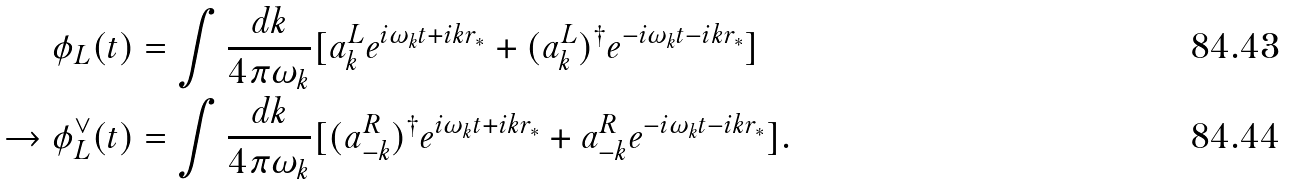<formula> <loc_0><loc_0><loc_500><loc_500>\phi _ { L } ( t ) & = \int \frac { d k } { 4 \pi \omega _ { k } } [ a ^ { L } _ { k } e ^ { i \omega _ { k } t + i k r _ { \ast } } + ( a _ { k } ^ { L } ) ^ { \dagger } e ^ { - i \omega _ { k } t - i k r _ { \ast } } ] \\ \to \phi _ { L } ^ { \vee } ( t ) & = \int \frac { d k } { 4 \pi \omega _ { k } } [ ( a ^ { R } _ { - k } ) ^ { \dagger } e ^ { i \omega _ { k } t + i k r _ { \ast } } + a _ { - k } ^ { R } e ^ { - i \omega _ { k } t - i k r _ { \ast } } ] .</formula> 